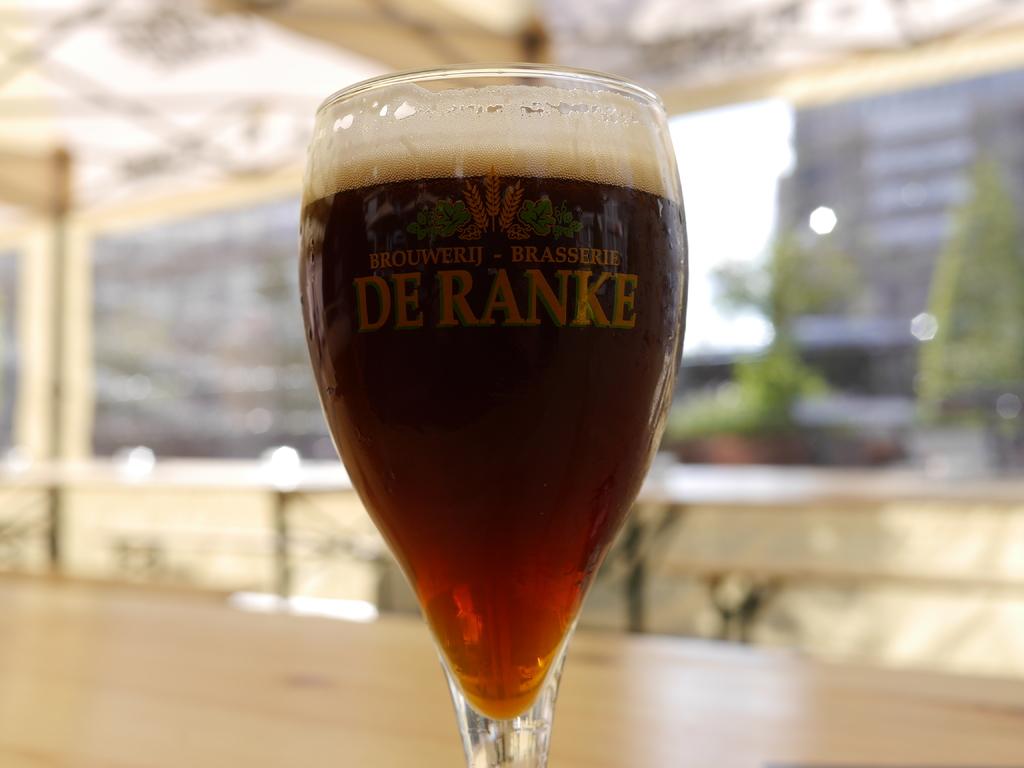What two words are written in the largest letters on this glass?
Keep it short and to the point. De ranke. 